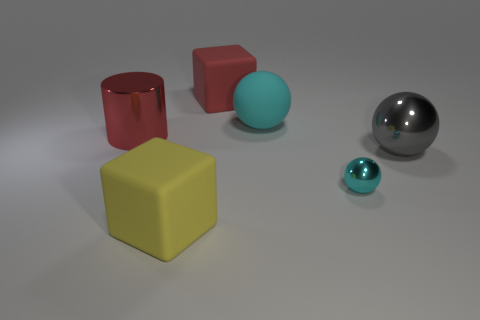Add 4 large gray shiny objects. How many objects exist? 10 Subtract all cubes. How many objects are left? 4 Add 5 big gray metallic spheres. How many big gray metallic spheres are left? 6 Add 4 large red matte cubes. How many large red matte cubes exist? 5 Subtract 0 blue cylinders. How many objects are left? 6 Subtract all large yellow rubber things. Subtract all large red shiny objects. How many objects are left? 4 